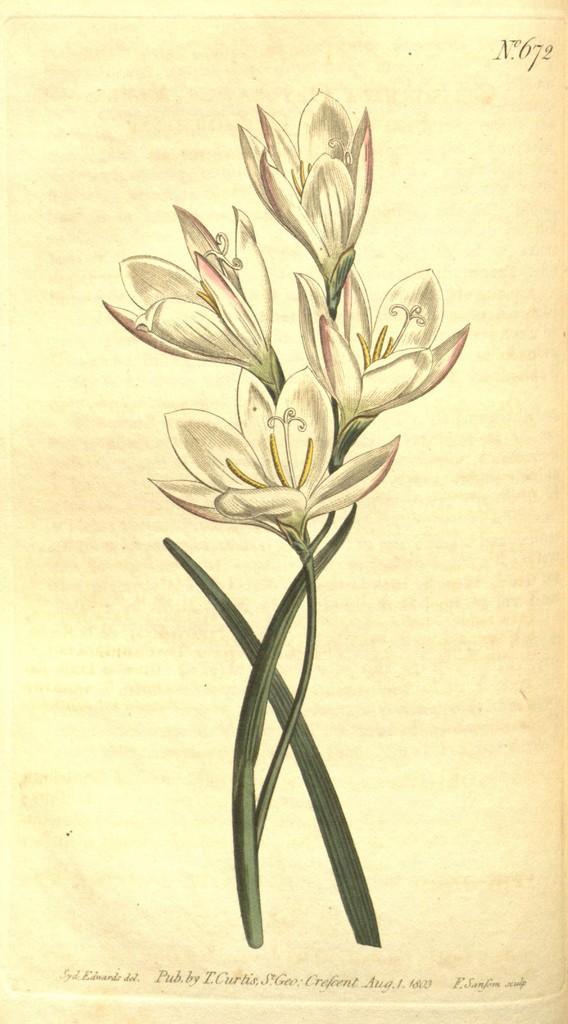In one or two sentences, can you explain what this image depicts? In this image, we can see a painting of some flowers and in the background, there is some text. 